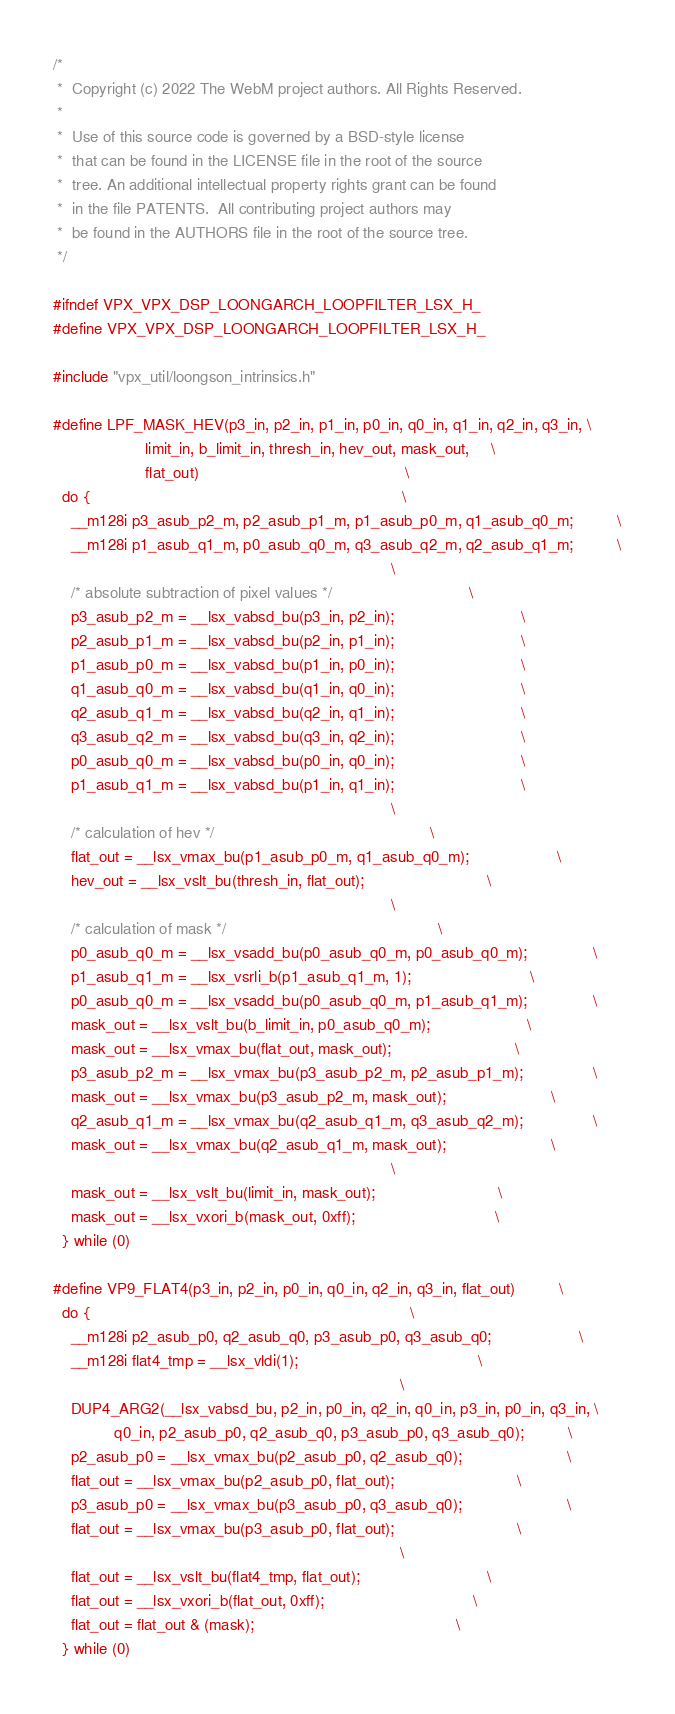<code> <loc_0><loc_0><loc_500><loc_500><_C_>/*
 *  Copyright (c) 2022 The WebM project authors. All Rights Reserved.
 *
 *  Use of this source code is governed by a BSD-style license
 *  that can be found in the LICENSE file in the root of the source
 *  tree. An additional intellectual property rights grant can be found
 *  in the file PATENTS.  All contributing project authors may
 *  be found in the AUTHORS file in the root of the source tree.
 */

#ifndef VPX_VPX_DSP_LOONGARCH_LOOPFILTER_LSX_H_
#define VPX_VPX_DSP_LOONGARCH_LOOPFILTER_LSX_H_

#include "vpx_util/loongson_intrinsics.h"

#define LPF_MASK_HEV(p3_in, p2_in, p1_in, p0_in, q0_in, q1_in, q2_in, q3_in, \
                     limit_in, b_limit_in, thresh_in, hev_out, mask_out,     \
                     flat_out)                                               \
  do {                                                                       \
    __m128i p3_asub_p2_m, p2_asub_p1_m, p1_asub_p0_m, q1_asub_q0_m;          \
    __m128i p1_asub_q1_m, p0_asub_q0_m, q3_asub_q2_m, q2_asub_q1_m;          \
                                                                             \
    /* absolute subtraction of pixel values */                               \
    p3_asub_p2_m = __lsx_vabsd_bu(p3_in, p2_in);                             \
    p2_asub_p1_m = __lsx_vabsd_bu(p2_in, p1_in);                             \
    p1_asub_p0_m = __lsx_vabsd_bu(p1_in, p0_in);                             \
    q1_asub_q0_m = __lsx_vabsd_bu(q1_in, q0_in);                             \
    q2_asub_q1_m = __lsx_vabsd_bu(q2_in, q1_in);                             \
    q3_asub_q2_m = __lsx_vabsd_bu(q3_in, q2_in);                             \
    p0_asub_q0_m = __lsx_vabsd_bu(p0_in, q0_in);                             \
    p1_asub_q1_m = __lsx_vabsd_bu(p1_in, q1_in);                             \
                                                                             \
    /* calculation of hev */                                                 \
    flat_out = __lsx_vmax_bu(p1_asub_p0_m, q1_asub_q0_m);                    \
    hev_out = __lsx_vslt_bu(thresh_in, flat_out);                            \
                                                                             \
    /* calculation of mask */                                                \
    p0_asub_q0_m = __lsx_vsadd_bu(p0_asub_q0_m, p0_asub_q0_m);               \
    p1_asub_q1_m = __lsx_vsrli_b(p1_asub_q1_m, 1);                           \
    p0_asub_q0_m = __lsx_vsadd_bu(p0_asub_q0_m, p1_asub_q1_m);               \
    mask_out = __lsx_vslt_bu(b_limit_in, p0_asub_q0_m);                      \
    mask_out = __lsx_vmax_bu(flat_out, mask_out);                            \
    p3_asub_p2_m = __lsx_vmax_bu(p3_asub_p2_m, p2_asub_p1_m);                \
    mask_out = __lsx_vmax_bu(p3_asub_p2_m, mask_out);                        \
    q2_asub_q1_m = __lsx_vmax_bu(q2_asub_q1_m, q3_asub_q2_m);                \
    mask_out = __lsx_vmax_bu(q2_asub_q1_m, mask_out);                        \
                                                                             \
    mask_out = __lsx_vslt_bu(limit_in, mask_out);                            \
    mask_out = __lsx_vxori_b(mask_out, 0xff);                                \
  } while (0)

#define VP9_FLAT4(p3_in, p2_in, p0_in, q0_in, q2_in, q3_in, flat_out)          \
  do {                                                                         \
    __m128i p2_asub_p0, q2_asub_q0, p3_asub_p0, q3_asub_q0;                    \
    __m128i flat4_tmp = __lsx_vldi(1);                                         \
                                                                               \
    DUP4_ARG2(__lsx_vabsd_bu, p2_in, p0_in, q2_in, q0_in, p3_in, p0_in, q3_in, \
              q0_in, p2_asub_p0, q2_asub_q0, p3_asub_p0, q3_asub_q0);          \
    p2_asub_p0 = __lsx_vmax_bu(p2_asub_p0, q2_asub_q0);                        \
    flat_out = __lsx_vmax_bu(p2_asub_p0, flat_out);                            \
    p3_asub_p0 = __lsx_vmax_bu(p3_asub_p0, q3_asub_q0);                        \
    flat_out = __lsx_vmax_bu(p3_asub_p0, flat_out);                            \
                                                                               \
    flat_out = __lsx_vslt_bu(flat4_tmp, flat_out);                             \
    flat_out = __lsx_vxori_b(flat_out, 0xff);                                  \
    flat_out = flat_out & (mask);                                              \
  } while (0)
</code> 